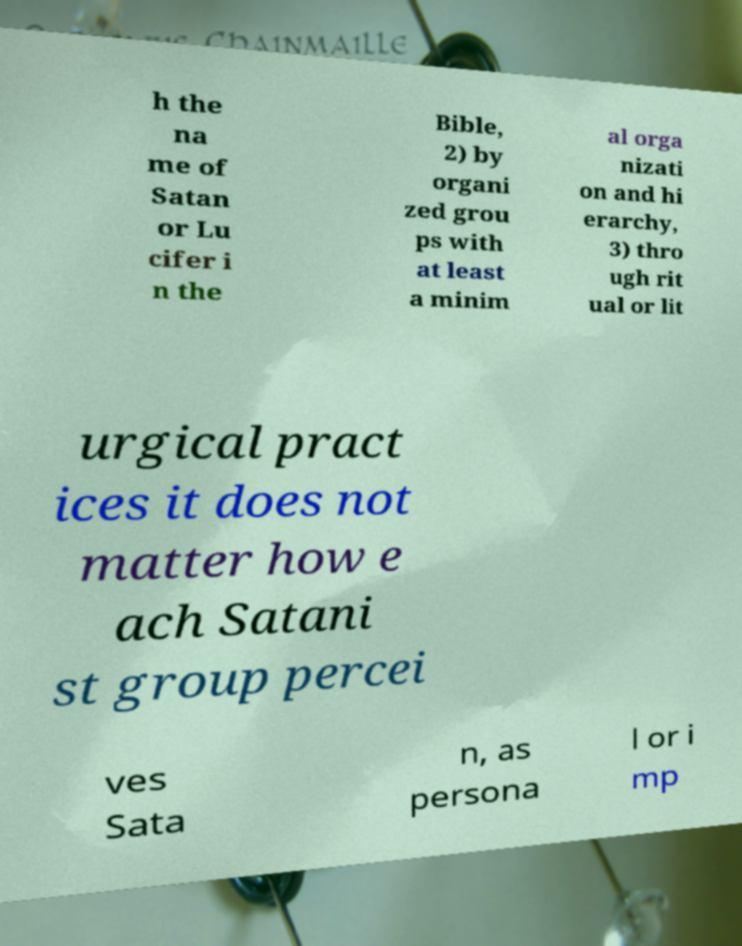Can you accurately transcribe the text from the provided image for me? h the na me of Satan or Lu cifer i n the Bible, 2) by organi zed grou ps with at least a minim al orga nizati on and hi erarchy, 3) thro ugh rit ual or lit urgical pract ices it does not matter how e ach Satani st group percei ves Sata n, as persona l or i mp 